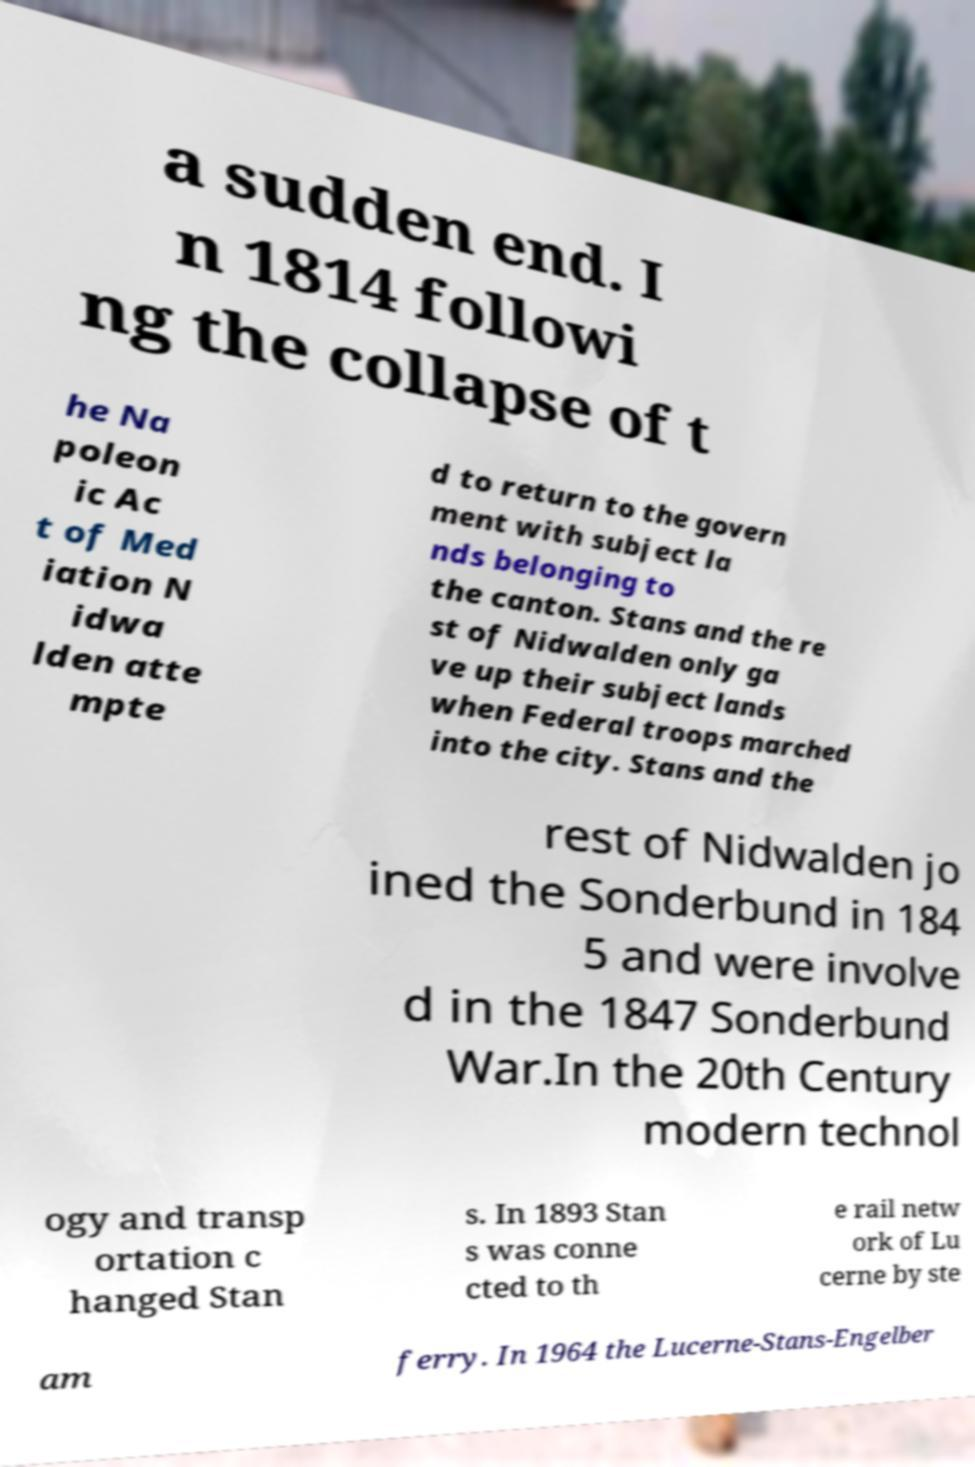Can you read and provide the text displayed in the image?This photo seems to have some interesting text. Can you extract and type it out for me? a sudden end. I n 1814 followi ng the collapse of t he Na poleon ic Ac t of Med iation N idwa lden atte mpte d to return to the govern ment with subject la nds belonging to the canton. Stans and the re st of Nidwalden only ga ve up their subject lands when Federal troops marched into the city. Stans and the rest of Nidwalden jo ined the Sonderbund in 184 5 and were involve d in the 1847 Sonderbund War.In the 20th Century modern technol ogy and transp ortation c hanged Stan s. In 1893 Stan s was conne cted to th e rail netw ork of Lu cerne by ste am ferry. In 1964 the Lucerne-Stans-Engelber 